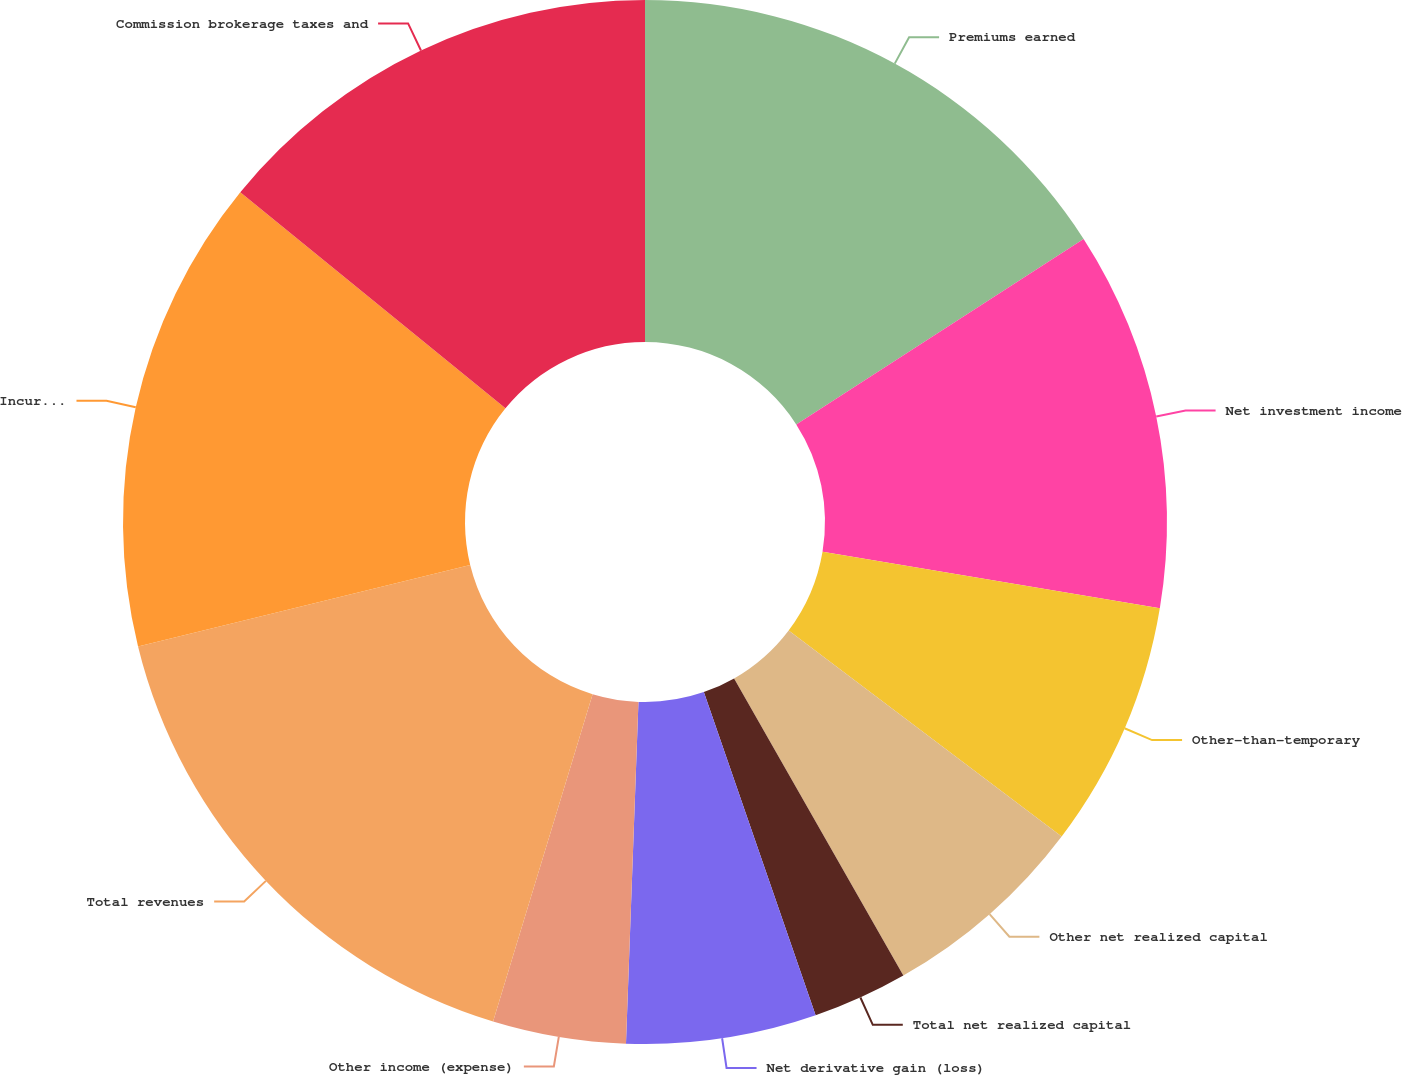Convert chart to OTSL. <chart><loc_0><loc_0><loc_500><loc_500><pie_chart><fcel>Premiums earned<fcel>Net investment income<fcel>Other-than-temporary<fcel>Other net realized capital<fcel>Total net realized capital<fcel>Net derivative gain (loss)<fcel>Other income (expense)<fcel>Total revenues<fcel>Incurred losses and loss<fcel>Commission brokerage taxes and<nl><fcel>15.88%<fcel>11.76%<fcel>7.65%<fcel>6.47%<fcel>2.94%<fcel>5.88%<fcel>4.12%<fcel>16.47%<fcel>14.71%<fcel>14.12%<nl></chart> 